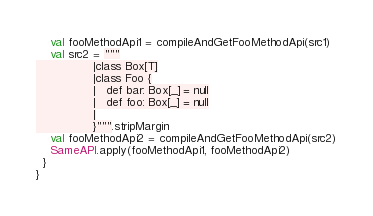<code> <loc_0><loc_0><loc_500><loc_500><_Scala_>    val fooMethodApi1 = compileAndGetFooMethodApi(src1)
    val src2 = """
				|class Box[T]
				|class Foo {
			    |   def bar: Box[_] = null
				|	def foo: Box[_] = null
				|
				}""".stripMargin
    val fooMethodApi2 = compileAndGetFooMethodApi(src2)
    SameAPI.apply(fooMethodApi1, fooMethodApi2)
  }
}
</code> 